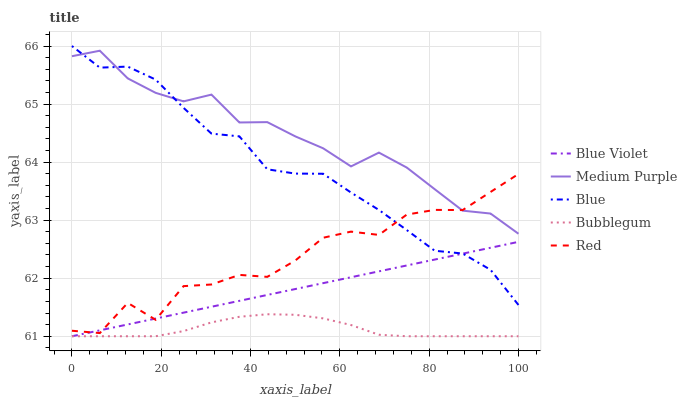Does Bubblegum have the minimum area under the curve?
Answer yes or no. Yes. Does Medium Purple have the maximum area under the curve?
Answer yes or no. Yes. Does Blue have the minimum area under the curve?
Answer yes or no. No. Does Blue have the maximum area under the curve?
Answer yes or no. No. Is Blue Violet the smoothest?
Answer yes or no. Yes. Is Red the roughest?
Answer yes or no. Yes. Is Blue the smoothest?
Answer yes or no. No. Is Blue the roughest?
Answer yes or no. No. Does Bubblegum have the lowest value?
Answer yes or no. Yes. Does Blue have the lowest value?
Answer yes or no. No. Does Blue have the highest value?
Answer yes or no. Yes. Does Red have the highest value?
Answer yes or no. No. Is Bubblegum less than Red?
Answer yes or no. Yes. Is Blue greater than Bubblegum?
Answer yes or no. Yes. Does Bubblegum intersect Blue Violet?
Answer yes or no. Yes. Is Bubblegum less than Blue Violet?
Answer yes or no. No. Is Bubblegum greater than Blue Violet?
Answer yes or no. No. Does Bubblegum intersect Red?
Answer yes or no. No. 